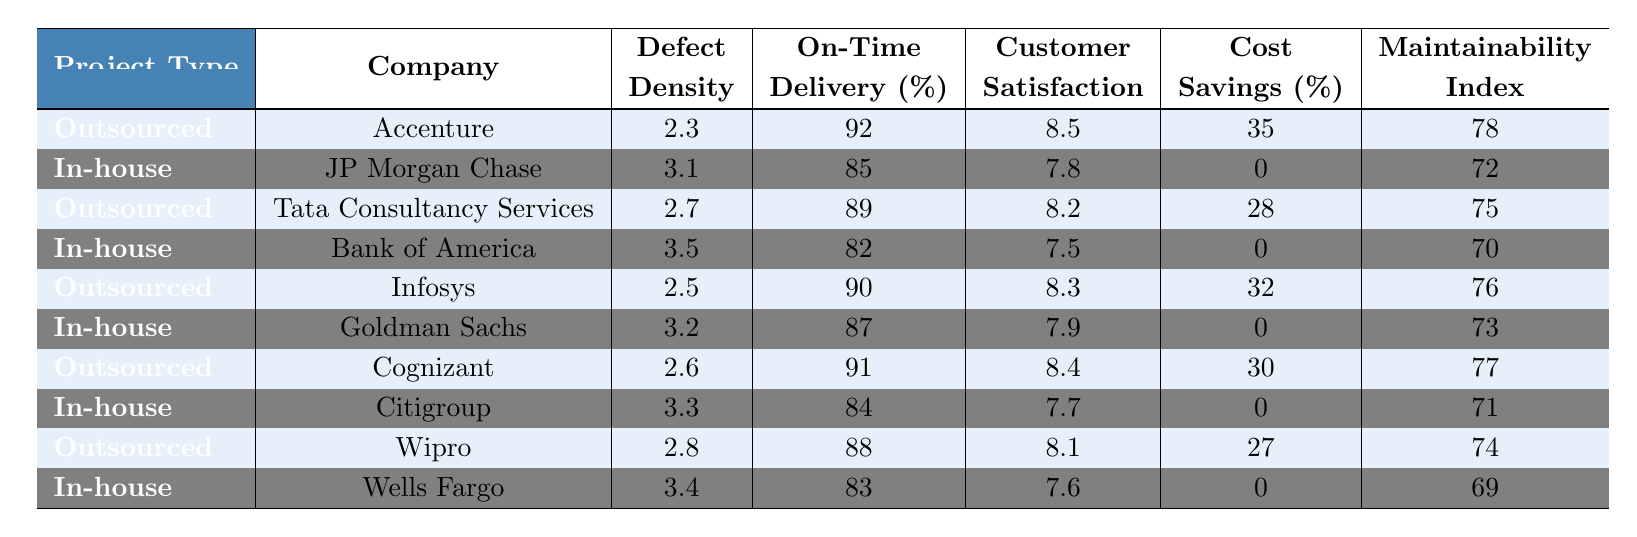What is the defect density for Accenture? The table shows that the defect density for Accenture under outsourced projects is 2.3 per 1000 lines of code.
Answer: 2.3 Which company delivered their project on time the most often? The percentage of on-time delivery for each company is listed. Accenture has 92%, which is the highest among the outsourced options. For in-house, JP Morgan Chase has 85%, which is still lower. Therefore, Accenture has the best delivery record overall at 92%.
Answer: Accenture What is the average customer satisfaction score for outsourced projects? The customer satisfaction scores for outsourced projects are: 8.5 (Accenture), 8.2 (TCS), 8.3 (Infosys), 8.4 (Cognizant), and 8.1 (Wipro). The sum of these scores is 8.5 + 8.2 + 8.3 + 8.4 + 8.1 = 41.5. There are 5 projects, so the average is 41.5 / 5 = 8.3.
Answer: 8.3 Is the cost savings for in-house projects ever greater than 0%? The table shows that for all in-house projects (JP Morgan Chase, Bank of America, Goldman Sachs, Citigroup, Wells Fargo), the cost savings percentage is 0%. Therefore, it is false that in-house projects show any cost savings.
Answer: No What is the difference in defect density between the best and worst-performing outsourced companies? The outsourced companies' defect densities are 2.3 (Accenture) and 2.8 (Wipro). To find the difference, subtract the best (2.3) from the worst (2.8): 2.8 - 2.3 = 0.5.
Answer: 0.5 Which in-house company has the highest maintainability index? The maintainability indices for the in-house projects are: 72 (JP Morgan Chase), 70 (Bank of America), 73 (Goldman Sachs), 71 (Citigroup), 69 (Wells Fargo). The highest is 73 for Goldman Sachs.
Answer: Goldman Sachs How does the on-time delivery percentage compare between the best-performing outsourced and in-house companies? The best-performing outsourced company is Accenture with 92% on-time delivery. The best-performing in-house company is JP Morgan Chase with 85%. The difference is significant, with outsourced outperforming in-house: 92% - 85% = 7%.
Answer: 7% Do any outsourced projects have a customer satisfaction score of 9 or higher? The scores listed under customer satisfaction for outsourced projects are all less than 9. Therefore, no outsourced projects have a score of 9 or higher.
Answer: No What is the total cost savings percentage across all outsourced projects? The cost savings percentages for outsourced projects are: 35 (Accenture), 28 (TCS), 32 (Infosys), 30 (Cognizant), and 27 (Wipro). Summing these, we have 35 + 28 + 32 + 30 + 27 = 152.
Answer: 152 Which project type (outsourced or in-house) generally has higher maintainability indices? The maintainability indices for outsourced projects are 78, 75, 76, 77, and 74. The average for outsourced is (78 + 75 + 76 + 77 + 74) / 5 = 76 for outsourced versus in-house's average of (72 + 70 + 73 + 71 + 69) / 5 = 71. Outsourced has higher indices.
Answer: Outsourced 